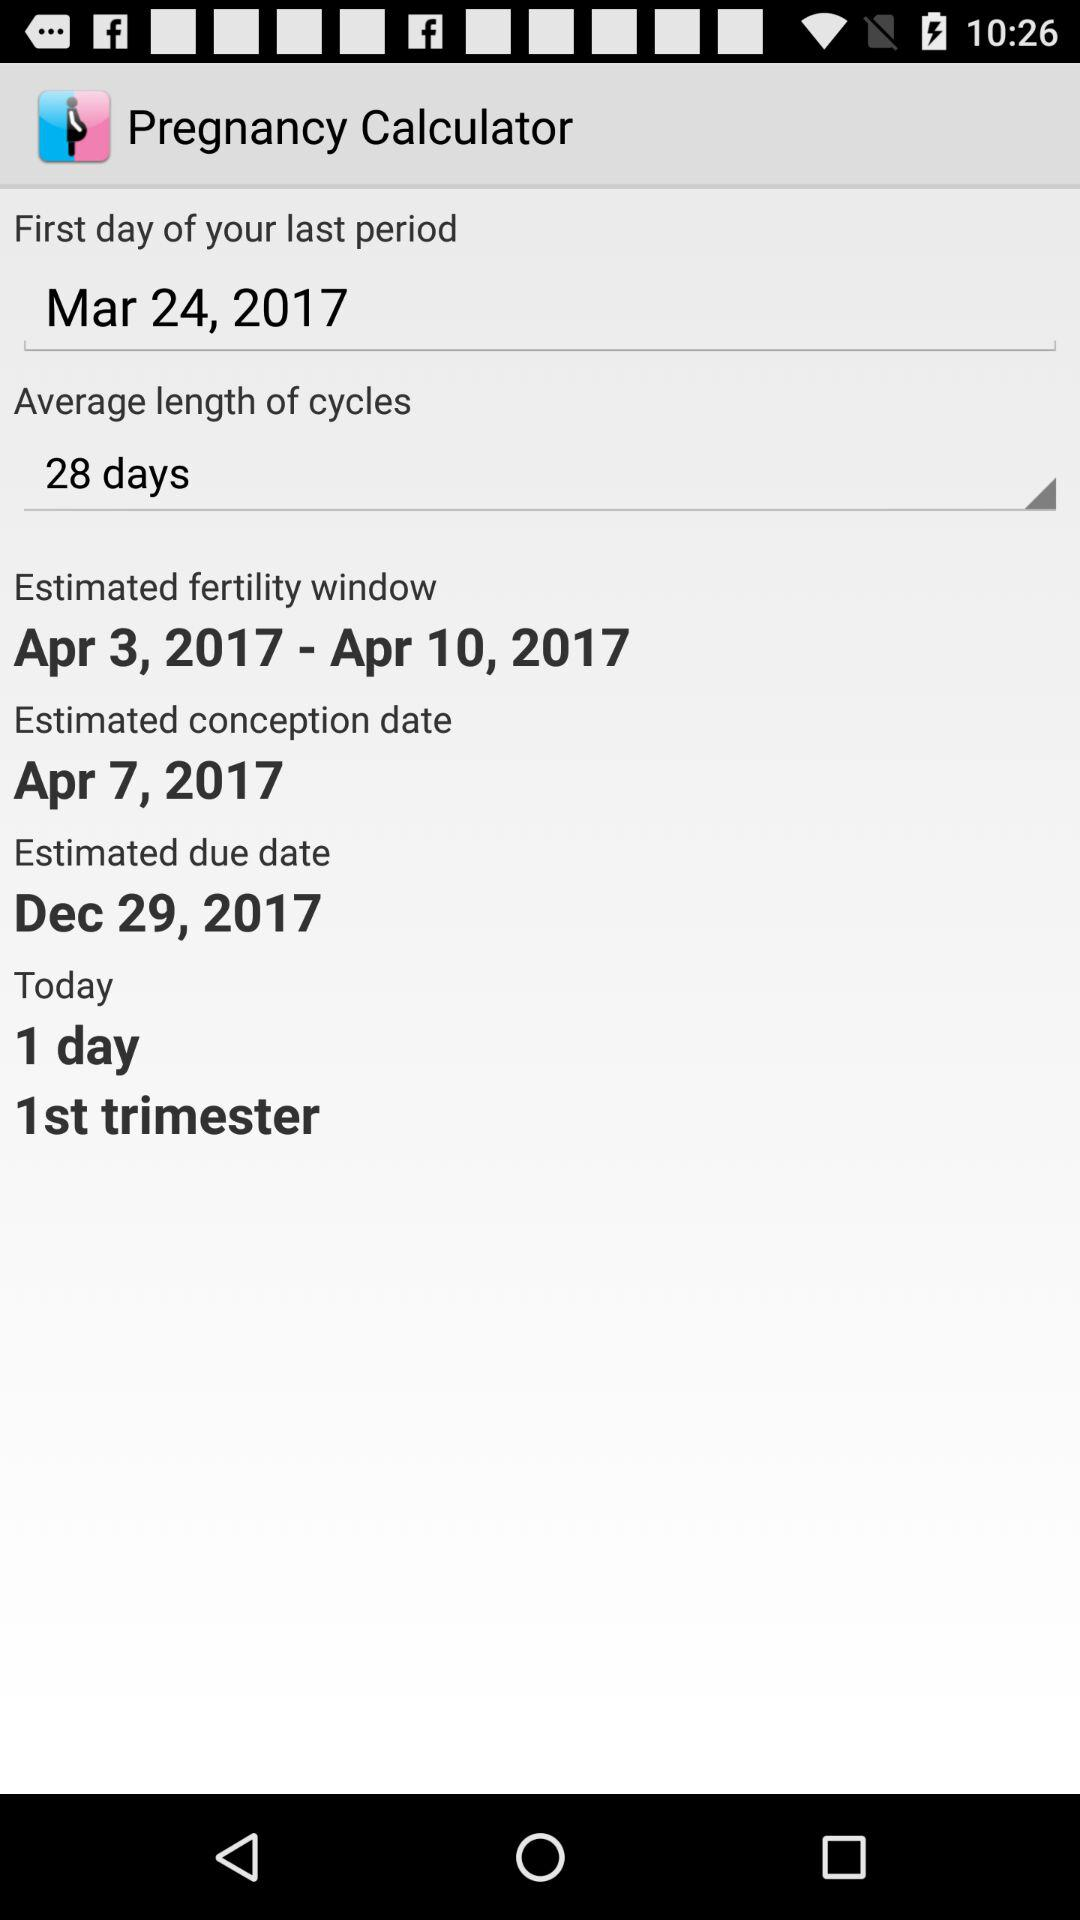What is the estimated due date? The estimated due date is December 29, 2017. 